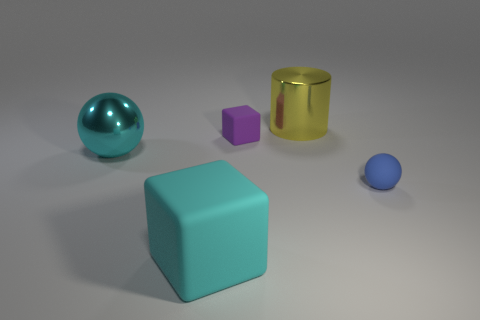How many cyan things have the same material as the tiny blue ball?
Your response must be concise. 1. Are there any purple rubber cubes that are to the right of the tiny matte thing that is in front of the matte object that is behind the large sphere?
Ensure brevity in your answer.  No. The small purple rubber object has what shape?
Provide a succinct answer. Cube. Do the tiny thing that is in front of the purple cube and the block that is in front of the small ball have the same material?
Offer a very short reply. Yes. How many large shiny spheres have the same color as the matte ball?
Your answer should be very brief. 0. What shape is the large thing that is behind the tiny matte sphere and to the left of the yellow thing?
Make the answer very short. Sphere. The rubber thing that is in front of the cyan shiny sphere and on the left side of the tiny sphere is what color?
Ensure brevity in your answer.  Cyan. Is the number of small purple matte cubes in front of the rubber ball greater than the number of small rubber spheres that are behind the tiny purple cube?
Make the answer very short. No. What is the color of the block that is behind the blue sphere?
Offer a very short reply. Purple. Is the shape of the big metallic thing that is in front of the large yellow cylinder the same as the small object that is right of the small purple rubber thing?
Give a very brief answer. Yes. 